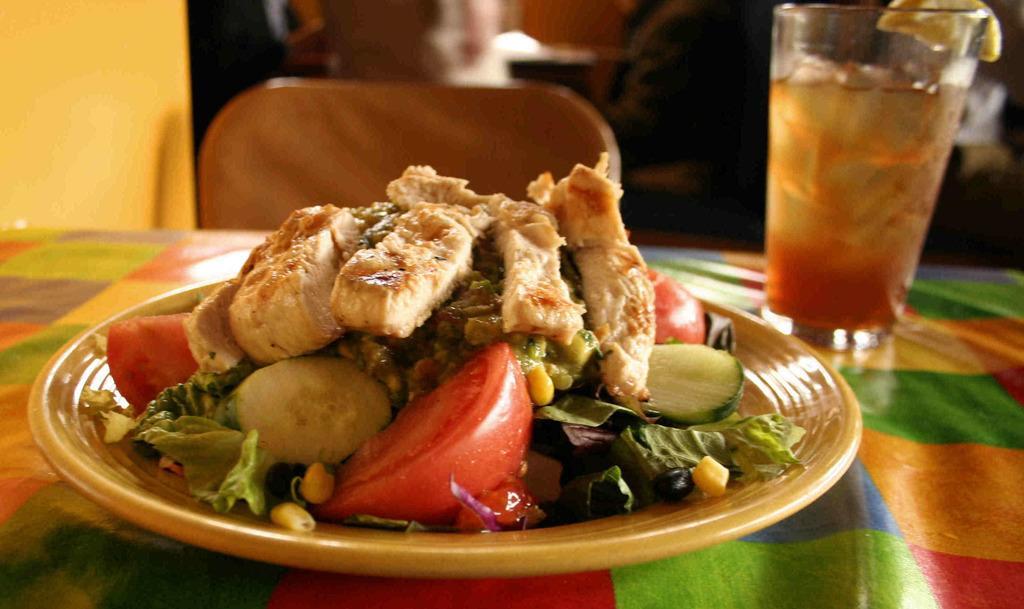Please provide a concise description of this image. This picture shows some veggies and meat in the plate on the table and we see a drink in the glass on the side and we see a chair to sit. 